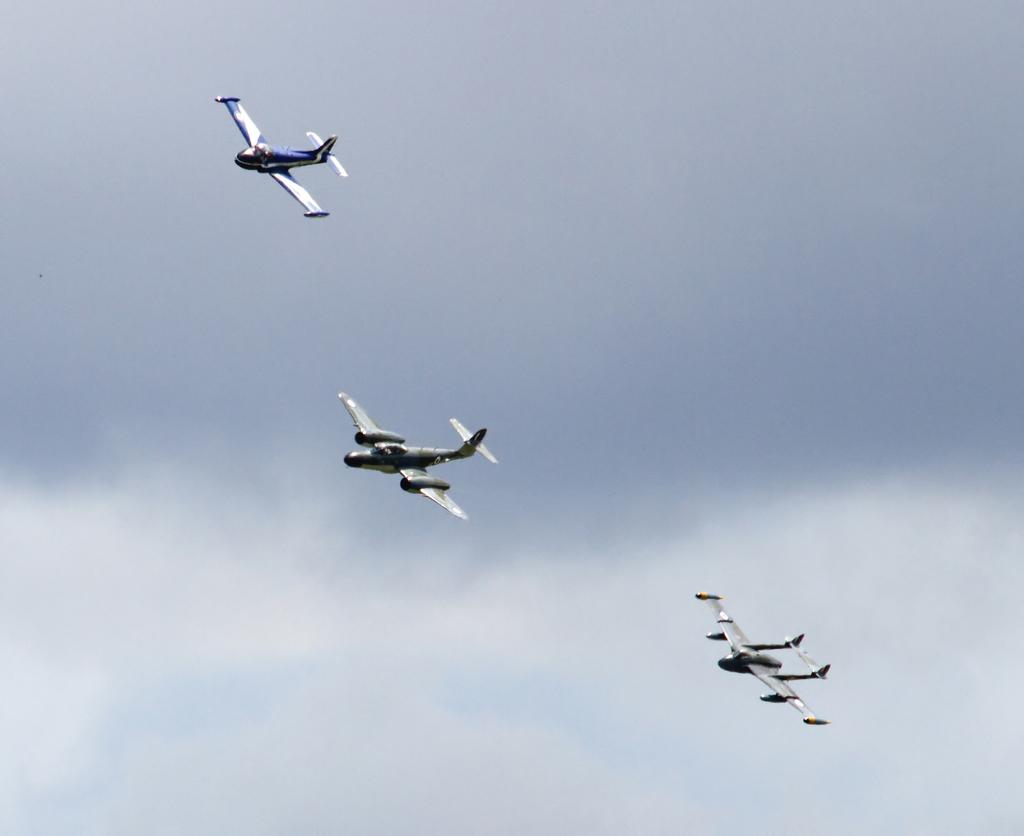What is happening in the sky in the image? There are aircraft flying in the sky. What is the condition of the sky in the image? The sky is cloudy. What type of popcorn can be seen floating in the sky in the image? There is no popcorn present in the image; it features aircraft flying in a cloudy sky. Can you see any stars in the sky in the image? The sky in the image is cloudy, so it is not possible to see any stars. 